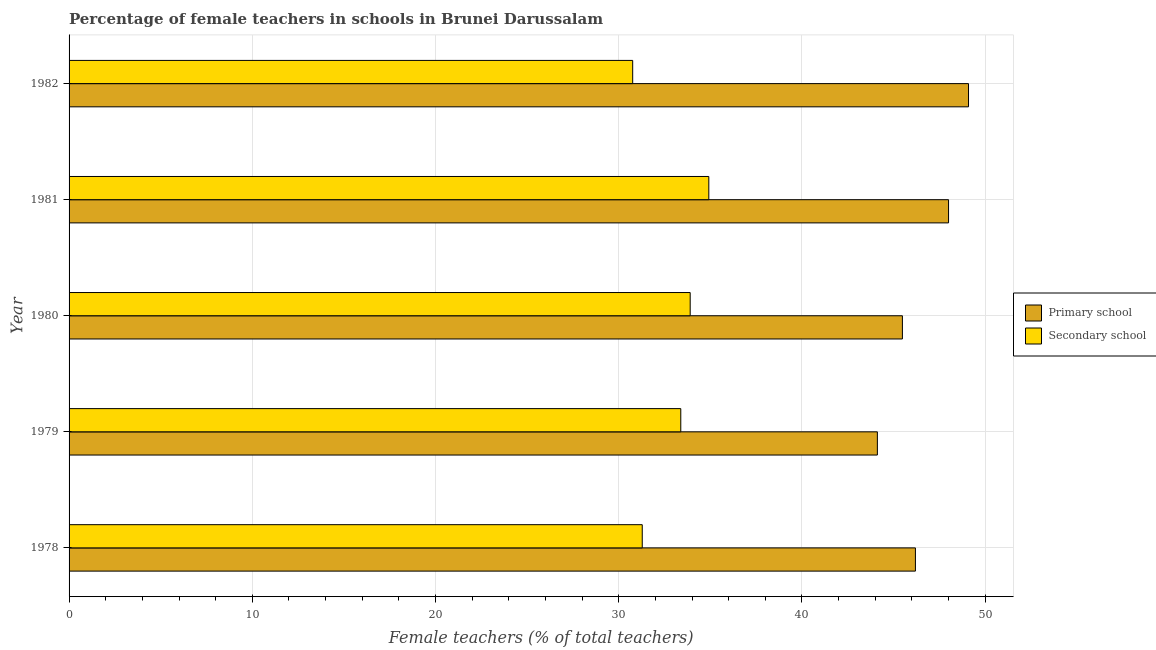How many different coloured bars are there?
Offer a terse response. 2. How many bars are there on the 2nd tick from the bottom?
Offer a very short reply. 2. In how many cases, is the number of bars for a given year not equal to the number of legend labels?
Keep it short and to the point. 0. What is the percentage of female teachers in primary schools in 1978?
Offer a terse response. 46.19. Across all years, what is the maximum percentage of female teachers in primary schools?
Your answer should be very brief. 49.09. Across all years, what is the minimum percentage of female teachers in primary schools?
Your answer should be compact. 44.12. In which year was the percentage of female teachers in primary schools maximum?
Your answer should be compact. 1982. In which year was the percentage of female teachers in primary schools minimum?
Your answer should be compact. 1979. What is the total percentage of female teachers in primary schools in the graph?
Your answer should be compact. 232.88. What is the difference between the percentage of female teachers in secondary schools in 1978 and that in 1981?
Make the answer very short. -3.63. What is the difference between the percentage of female teachers in secondary schools in 1981 and the percentage of female teachers in primary schools in 1978?
Offer a very short reply. -11.28. What is the average percentage of female teachers in secondary schools per year?
Provide a short and direct response. 32.85. In the year 1979, what is the difference between the percentage of female teachers in secondary schools and percentage of female teachers in primary schools?
Provide a succinct answer. -10.73. What is the ratio of the percentage of female teachers in primary schools in 1978 to that in 1982?
Ensure brevity in your answer.  0.94. Is the difference between the percentage of female teachers in primary schools in 1978 and 1981 greater than the difference between the percentage of female teachers in secondary schools in 1978 and 1981?
Your answer should be compact. Yes. What is the difference between the highest and the second highest percentage of female teachers in primary schools?
Your answer should be compact. 1.09. What is the difference between the highest and the lowest percentage of female teachers in primary schools?
Your answer should be very brief. 4.97. Is the sum of the percentage of female teachers in primary schools in 1978 and 1982 greater than the maximum percentage of female teachers in secondary schools across all years?
Your answer should be very brief. Yes. What does the 2nd bar from the top in 1980 represents?
Make the answer very short. Primary school. What does the 2nd bar from the bottom in 1979 represents?
Provide a succinct answer. Secondary school. Are all the bars in the graph horizontal?
Your answer should be compact. Yes. How many years are there in the graph?
Offer a terse response. 5. What is the difference between two consecutive major ticks on the X-axis?
Your answer should be very brief. 10. Does the graph contain any zero values?
Offer a terse response. No. How many legend labels are there?
Offer a terse response. 2. What is the title of the graph?
Give a very brief answer. Percentage of female teachers in schools in Brunei Darussalam. Does "Stunting" appear as one of the legend labels in the graph?
Keep it short and to the point. No. What is the label or title of the X-axis?
Your response must be concise. Female teachers (% of total teachers). What is the Female teachers (% of total teachers) of Primary school in 1978?
Your response must be concise. 46.19. What is the Female teachers (% of total teachers) of Secondary school in 1978?
Your answer should be very brief. 31.28. What is the Female teachers (% of total teachers) in Primary school in 1979?
Your response must be concise. 44.12. What is the Female teachers (% of total teachers) of Secondary school in 1979?
Offer a terse response. 33.39. What is the Female teachers (% of total teachers) in Primary school in 1980?
Offer a terse response. 45.48. What is the Female teachers (% of total teachers) in Secondary school in 1980?
Your answer should be very brief. 33.9. What is the Female teachers (% of total teachers) in Secondary school in 1981?
Make the answer very short. 34.92. What is the Female teachers (% of total teachers) of Primary school in 1982?
Provide a succinct answer. 49.09. What is the Female teachers (% of total teachers) in Secondary school in 1982?
Offer a terse response. 30.76. Across all years, what is the maximum Female teachers (% of total teachers) in Primary school?
Provide a short and direct response. 49.09. Across all years, what is the maximum Female teachers (% of total teachers) in Secondary school?
Provide a succinct answer. 34.92. Across all years, what is the minimum Female teachers (% of total teachers) in Primary school?
Offer a terse response. 44.12. Across all years, what is the minimum Female teachers (% of total teachers) in Secondary school?
Provide a short and direct response. 30.76. What is the total Female teachers (% of total teachers) of Primary school in the graph?
Offer a very short reply. 232.88. What is the total Female teachers (% of total teachers) of Secondary school in the graph?
Ensure brevity in your answer.  164.24. What is the difference between the Female teachers (% of total teachers) of Primary school in 1978 and that in 1979?
Keep it short and to the point. 2.08. What is the difference between the Female teachers (% of total teachers) of Secondary school in 1978 and that in 1979?
Make the answer very short. -2.1. What is the difference between the Female teachers (% of total teachers) in Primary school in 1978 and that in 1980?
Your answer should be compact. 0.71. What is the difference between the Female teachers (% of total teachers) in Secondary school in 1978 and that in 1980?
Your answer should be very brief. -2.62. What is the difference between the Female teachers (% of total teachers) of Primary school in 1978 and that in 1981?
Your answer should be compact. -1.81. What is the difference between the Female teachers (% of total teachers) of Secondary school in 1978 and that in 1981?
Give a very brief answer. -3.63. What is the difference between the Female teachers (% of total teachers) in Primary school in 1978 and that in 1982?
Keep it short and to the point. -2.9. What is the difference between the Female teachers (% of total teachers) in Secondary school in 1978 and that in 1982?
Offer a terse response. 0.52. What is the difference between the Female teachers (% of total teachers) of Primary school in 1979 and that in 1980?
Give a very brief answer. -1.37. What is the difference between the Female teachers (% of total teachers) of Secondary school in 1979 and that in 1980?
Offer a very short reply. -0.51. What is the difference between the Female teachers (% of total teachers) of Primary school in 1979 and that in 1981?
Keep it short and to the point. -3.88. What is the difference between the Female teachers (% of total teachers) of Secondary school in 1979 and that in 1981?
Your response must be concise. -1.53. What is the difference between the Female teachers (% of total teachers) in Primary school in 1979 and that in 1982?
Make the answer very short. -4.97. What is the difference between the Female teachers (% of total teachers) in Secondary school in 1979 and that in 1982?
Your answer should be very brief. 2.62. What is the difference between the Female teachers (% of total teachers) in Primary school in 1980 and that in 1981?
Offer a very short reply. -2.52. What is the difference between the Female teachers (% of total teachers) of Secondary school in 1980 and that in 1981?
Your answer should be compact. -1.02. What is the difference between the Female teachers (% of total teachers) in Primary school in 1980 and that in 1982?
Make the answer very short. -3.61. What is the difference between the Female teachers (% of total teachers) of Secondary school in 1980 and that in 1982?
Your answer should be compact. 3.14. What is the difference between the Female teachers (% of total teachers) in Primary school in 1981 and that in 1982?
Your answer should be compact. -1.09. What is the difference between the Female teachers (% of total teachers) in Secondary school in 1981 and that in 1982?
Keep it short and to the point. 4.15. What is the difference between the Female teachers (% of total teachers) in Primary school in 1978 and the Female teachers (% of total teachers) in Secondary school in 1979?
Your response must be concise. 12.81. What is the difference between the Female teachers (% of total teachers) in Primary school in 1978 and the Female teachers (% of total teachers) in Secondary school in 1980?
Your answer should be compact. 12.29. What is the difference between the Female teachers (% of total teachers) of Primary school in 1978 and the Female teachers (% of total teachers) of Secondary school in 1981?
Your response must be concise. 11.28. What is the difference between the Female teachers (% of total teachers) in Primary school in 1978 and the Female teachers (% of total teachers) in Secondary school in 1982?
Offer a terse response. 15.43. What is the difference between the Female teachers (% of total teachers) in Primary school in 1979 and the Female teachers (% of total teachers) in Secondary school in 1980?
Provide a short and direct response. 10.22. What is the difference between the Female teachers (% of total teachers) in Primary school in 1979 and the Female teachers (% of total teachers) in Secondary school in 1981?
Your response must be concise. 9.2. What is the difference between the Female teachers (% of total teachers) in Primary school in 1979 and the Female teachers (% of total teachers) in Secondary school in 1982?
Your answer should be compact. 13.36. What is the difference between the Female teachers (% of total teachers) in Primary school in 1980 and the Female teachers (% of total teachers) in Secondary school in 1981?
Your response must be concise. 10.57. What is the difference between the Female teachers (% of total teachers) in Primary school in 1980 and the Female teachers (% of total teachers) in Secondary school in 1982?
Offer a very short reply. 14.72. What is the difference between the Female teachers (% of total teachers) of Primary school in 1981 and the Female teachers (% of total teachers) of Secondary school in 1982?
Give a very brief answer. 17.24. What is the average Female teachers (% of total teachers) in Primary school per year?
Provide a short and direct response. 46.58. What is the average Female teachers (% of total teachers) in Secondary school per year?
Your answer should be very brief. 32.85. In the year 1978, what is the difference between the Female teachers (% of total teachers) in Primary school and Female teachers (% of total teachers) in Secondary school?
Offer a very short reply. 14.91. In the year 1979, what is the difference between the Female teachers (% of total teachers) of Primary school and Female teachers (% of total teachers) of Secondary school?
Give a very brief answer. 10.73. In the year 1980, what is the difference between the Female teachers (% of total teachers) of Primary school and Female teachers (% of total teachers) of Secondary school?
Give a very brief answer. 11.58. In the year 1981, what is the difference between the Female teachers (% of total teachers) of Primary school and Female teachers (% of total teachers) of Secondary school?
Provide a short and direct response. 13.08. In the year 1982, what is the difference between the Female teachers (% of total teachers) in Primary school and Female teachers (% of total teachers) in Secondary school?
Give a very brief answer. 18.33. What is the ratio of the Female teachers (% of total teachers) of Primary school in 1978 to that in 1979?
Provide a succinct answer. 1.05. What is the ratio of the Female teachers (% of total teachers) in Secondary school in 1978 to that in 1979?
Your answer should be very brief. 0.94. What is the ratio of the Female teachers (% of total teachers) in Primary school in 1978 to that in 1980?
Provide a short and direct response. 1.02. What is the ratio of the Female teachers (% of total teachers) of Secondary school in 1978 to that in 1980?
Provide a succinct answer. 0.92. What is the ratio of the Female teachers (% of total teachers) of Primary school in 1978 to that in 1981?
Your response must be concise. 0.96. What is the ratio of the Female teachers (% of total teachers) in Secondary school in 1978 to that in 1981?
Offer a very short reply. 0.9. What is the ratio of the Female teachers (% of total teachers) in Primary school in 1978 to that in 1982?
Keep it short and to the point. 0.94. What is the ratio of the Female teachers (% of total teachers) of Primary school in 1979 to that in 1980?
Your answer should be compact. 0.97. What is the ratio of the Female teachers (% of total teachers) of Primary school in 1979 to that in 1981?
Offer a terse response. 0.92. What is the ratio of the Female teachers (% of total teachers) in Secondary school in 1979 to that in 1981?
Give a very brief answer. 0.96. What is the ratio of the Female teachers (% of total teachers) of Primary school in 1979 to that in 1982?
Provide a succinct answer. 0.9. What is the ratio of the Female teachers (% of total teachers) in Secondary school in 1979 to that in 1982?
Offer a very short reply. 1.09. What is the ratio of the Female teachers (% of total teachers) of Primary school in 1980 to that in 1981?
Offer a terse response. 0.95. What is the ratio of the Female teachers (% of total teachers) in Secondary school in 1980 to that in 1981?
Your answer should be very brief. 0.97. What is the ratio of the Female teachers (% of total teachers) of Primary school in 1980 to that in 1982?
Your answer should be very brief. 0.93. What is the ratio of the Female teachers (% of total teachers) of Secondary school in 1980 to that in 1982?
Keep it short and to the point. 1.1. What is the ratio of the Female teachers (% of total teachers) of Primary school in 1981 to that in 1982?
Ensure brevity in your answer.  0.98. What is the ratio of the Female teachers (% of total teachers) in Secondary school in 1981 to that in 1982?
Provide a short and direct response. 1.14. What is the difference between the highest and the second highest Female teachers (% of total teachers) of Primary school?
Provide a succinct answer. 1.09. What is the difference between the highest and the lowest Female teachers (% of total teachers) of Primary school?
Make the answer very short. 4.97. What is the difference between the highest and the lowest Female teachers (% of total teachers) of Secondary school?
Your answer should be compact. 4.15. 